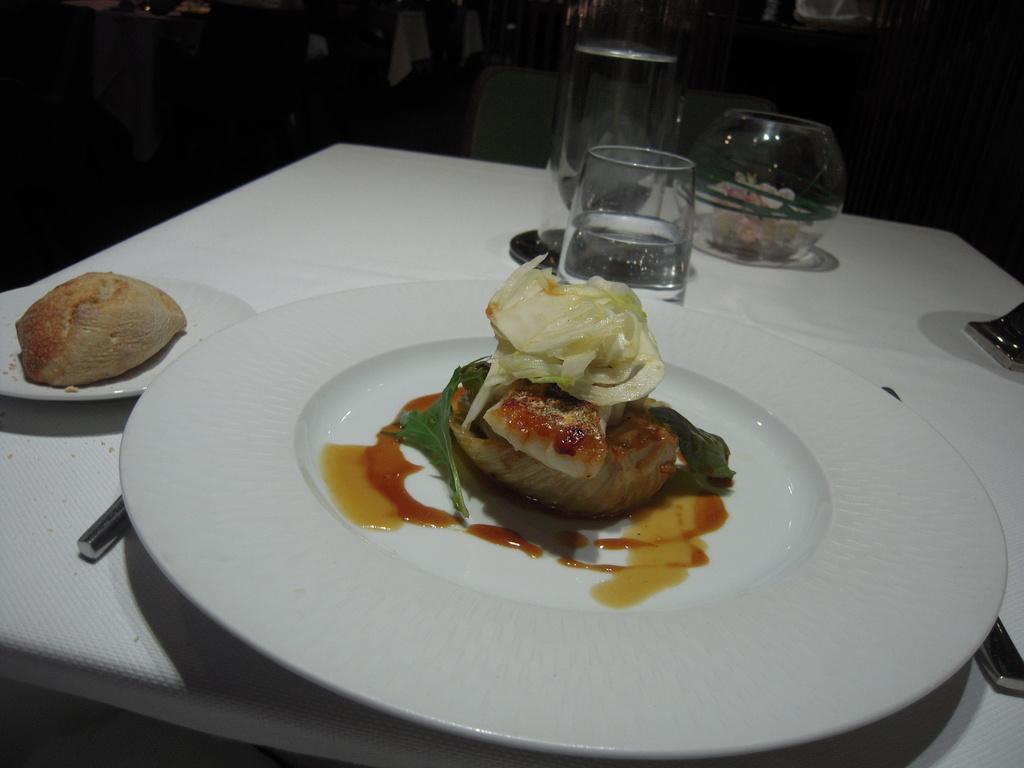Could you give a brief overview of what you see in this image? In this image we can see a table on which group of glasses ,plates ,spoons are placed on it. On the plates we can see food. In the background ,we can see chairs. 